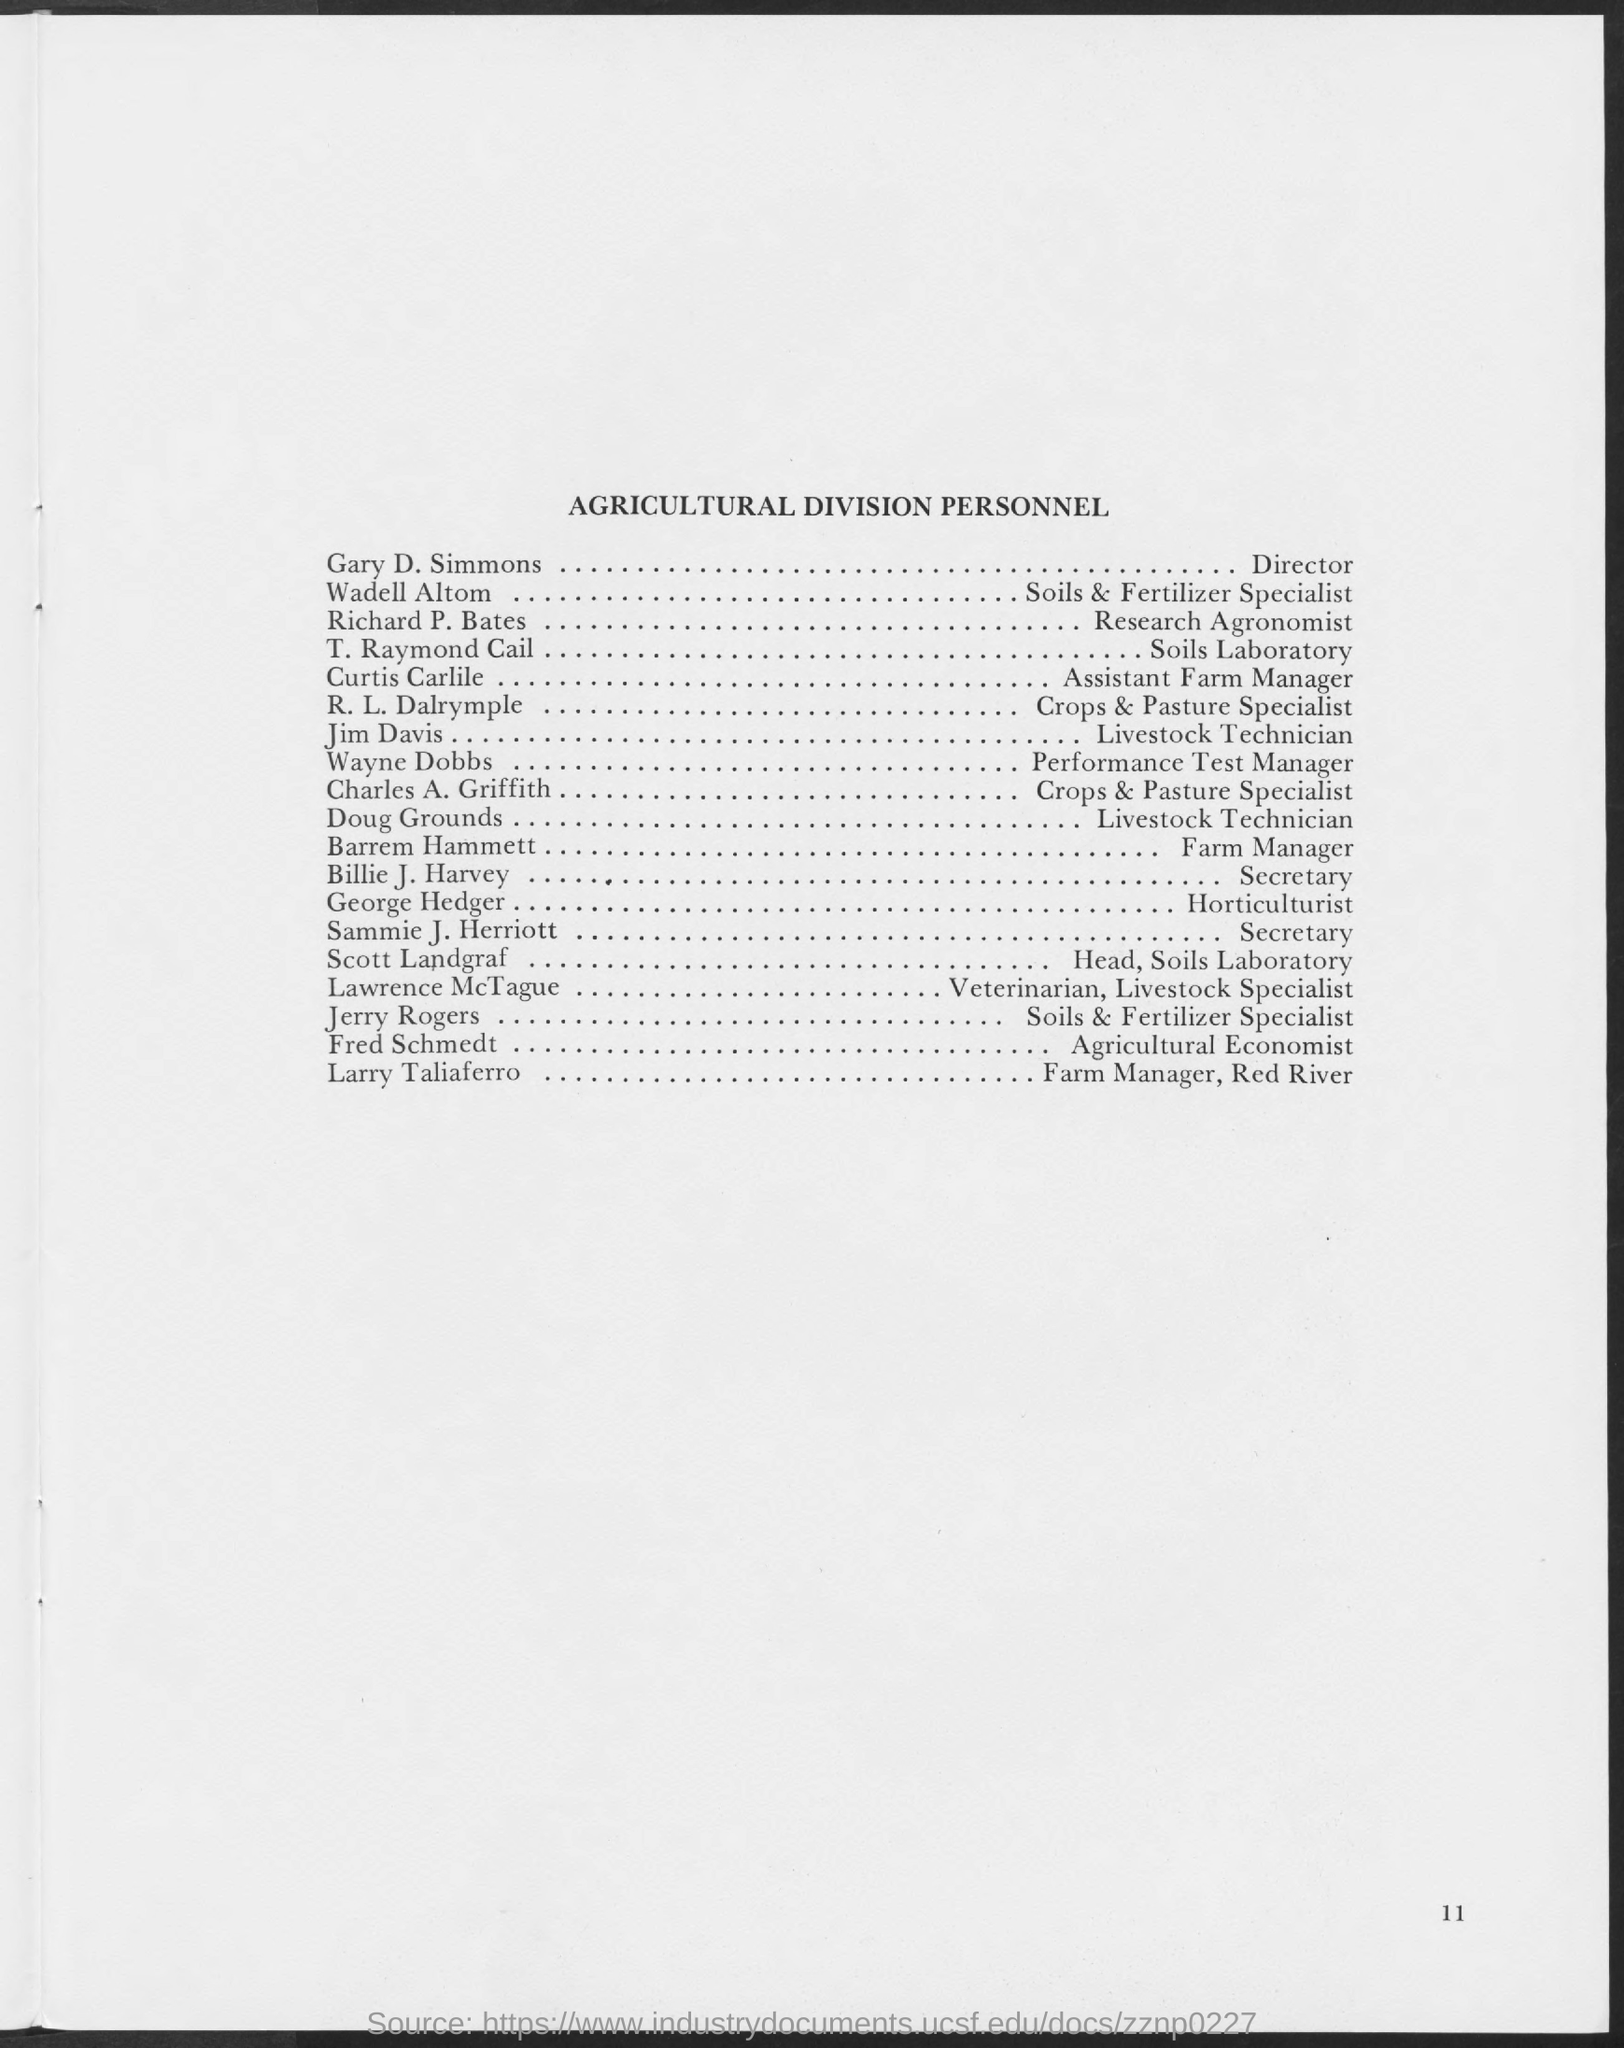Specify some key components in this picture. Richard P. Bates is a Research Agronomist with a designation. Lawrence McTague is a veterinarian and livestock specialist. Wayne Dobbs' designation is Performance Test Manager. Fred Schmedt is an agricultural economist. The Farm Manager at Red River of the Agricultural Division is Larry Taliifero. 